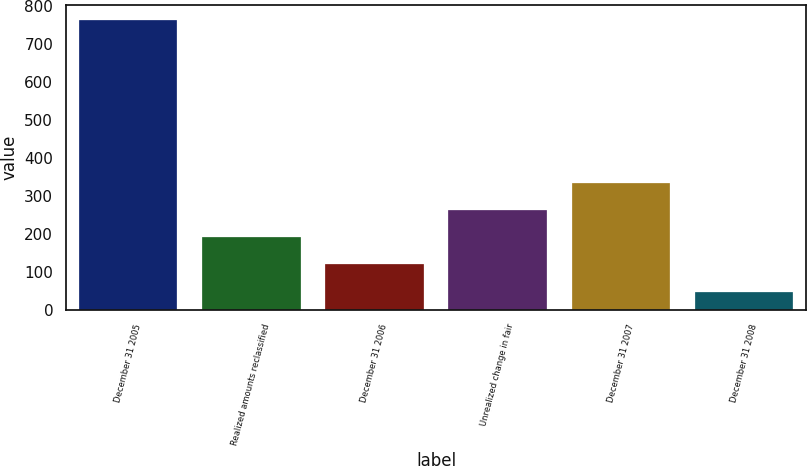Convert chart. <chart><loc_0><loc_0><loc_500><loc_500><bar_chart><fcel>December 31 2005<fcel>Realized amounts reclassified<fcel>December 31 2006<fcel>Unrealized change in fair<fcel>December 31 2007<fcel>December 31 2008<nl><fcel>764<fcel>191.2<fcel>119.6<fcel>262.8<fcel>334.4<fcel>48<nl></chart> 